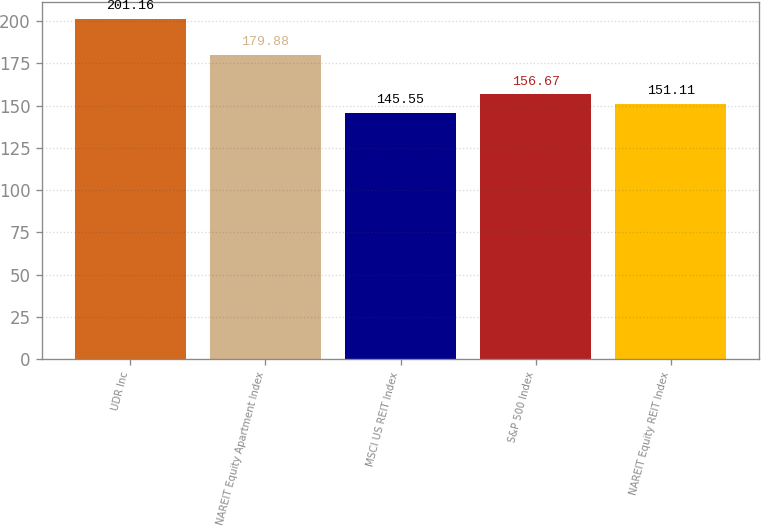Convert chart. <chart><loc_0><loc_0><loc_500><loc_500><bar_chart><fcel>UDR Inc<fcel>NAREIT Equity Apartment Index<fcel>MSCI US REIT Index<fcel>S&P 500 Index<fcel>NAREIT Equity REIT Index<nl><fcel>201.16<fcel>179.88<fcel>145.55<fcel>156.67<fcel>151.11<nl></chart> 